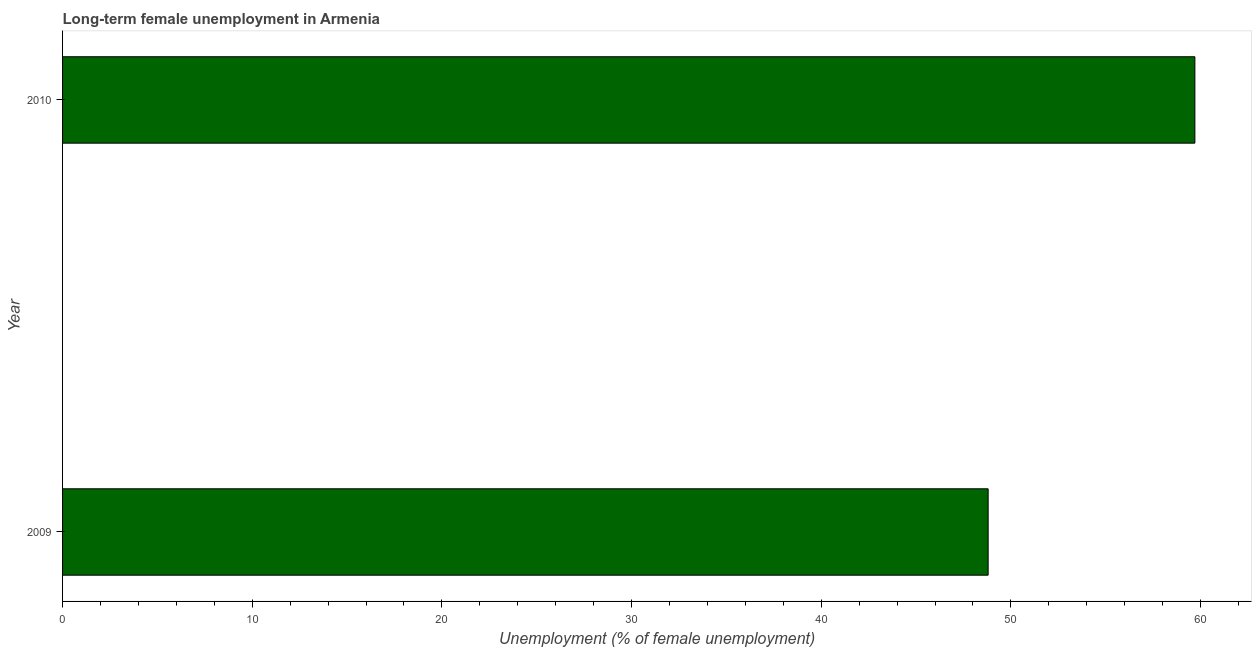Does the graph contain grids?
Your answer should be compact. No. What is the title of the graph?
Ensure brevity in your answer.  Long-term female unemployment in Armenia. What is the label or title of the X-axis?
Offer a very short reply. Unemployment (% of female unemployment). What is the long-term female unemployment in 2010?
Offer a very short reply. 59.7. Across all years, what is the maximum long-term female unemployment?
Offer a terse response. 59.7. Across all years, what is the minimum long-term female unemployment?
Give a very brief answer. 48.8. In which year was the long-term female unemployment maximum?
Your response must be concise. 2010. In which year was the long-term female unemployment minimum?
Keep it short and to the point. 2009. What is the sum of the long-term female unemployment?
Make the answer very short. 108.5. What is the difference between the long-term female unemployment in 2009 and 2010?
Keep it short and to the point. -10.9. What is the average long-term female unemployment per year?
Give a very brief answer. 54.25. What is the median long-term female unemployment?
Offer a very short reply. 54.25. Do a majority of the years between 2009 and 2010 (inclusive) have long-term female unemployment greater than 36 %?
Offer a terse response. Yes. What is the ratio of the long-term female unemployment in 2009 to that in 2010?
Your answer should be compact. 0.82. Is the long-term female unemployment in 2009 less than that in 2010?
Offer a terse response. Yes. What is the difference between two consecutive major ticks on the X-axis?
Offer a terse response. 10. What is the Unemployment (% of female unemployment) of 2009?
Your response must be concise. 48.8. What is the Unemployment (% of female unemployment) of 2010?
Your response must be concise. 59.7. What is the difference between the Unemployment (% of female unemployment) in 2009 and 2010?
Your answer should be compact. -10.9. What is the ratio of the Unemployment (% of female unemployment) in 2009 to that in 2010?
Offer a very short reply. 0.82. 